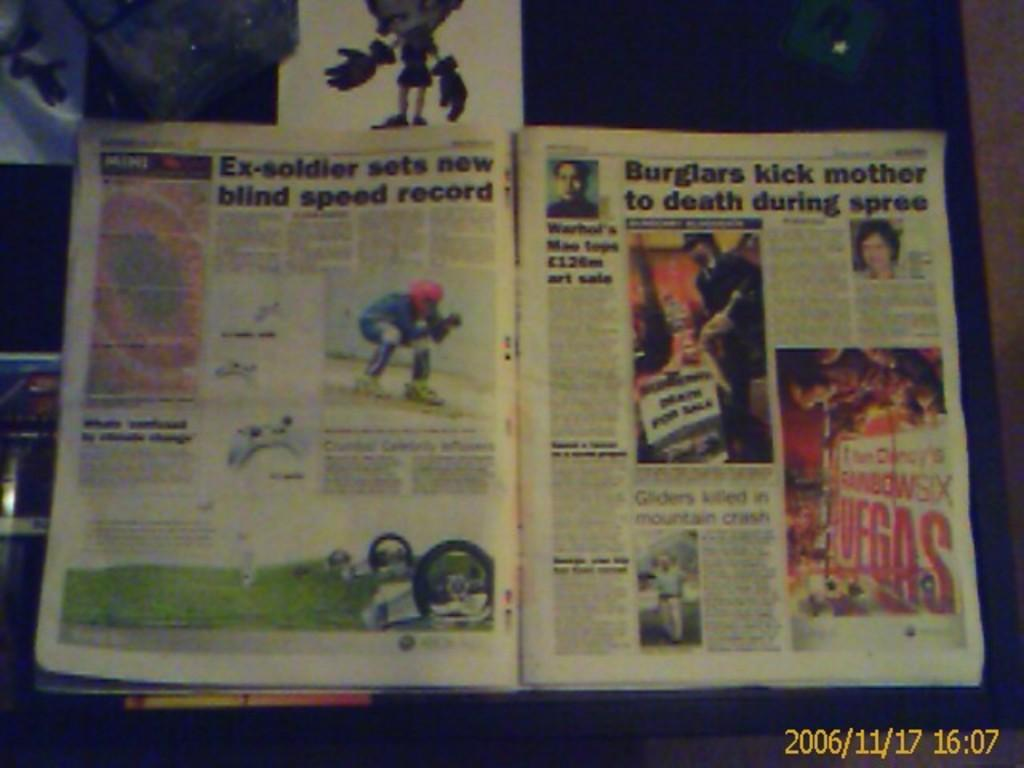Provide a one-sentence caption for the provided image. A page of a magazine with the title "Ex-soldier sets new blind speed record" on it. 